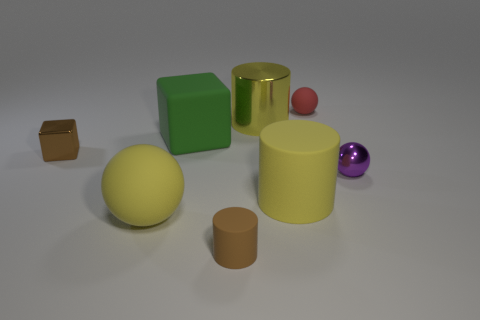Is there any other thing that is the same color as the matte cube?
Provide a succinct answer. No. Is there a red thing made of the same material as the small brown cylinder?
Provide a short and direct response. Yes. What color is the matte block?
Provide a succinct answer. Green. There is a matte thing that is the same color as the shiny block; what is its shape?
Offer a very short reply. Cylinder. There is a rubber ball that is the same size as the purple metal object; what color is it?
Your answer should be compact. Red. How many rubber objects are either small brown things or brown cubes?
Offer a terse response. 1. How many tiny objects are left of the tiny red object and behind the tiny purple shiny ball?
Ensure brevity in your answer.  1. Is there anything else that has the same shape as the brown metallic thing?
Make the answer very short. Yes. What number of other things are there of the same size as the yellow shiny object?
Your answer should be very brief. 3. There is a yellow cylinder behind the small brown block; is it the same size as the yellow thing on the left side of the brown rubber cylinder?
Provide a succinct answer. Yes. 